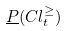Convert formula to latex. <formula><loc_0><loc_0><loc_500><loc_500>\underline { P } ( C l _ { t } ^ { \geq } )</formula> 